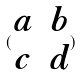Convert formula to latex. <formula><loc_0><loc_0><loc_500><loc_500>( \begin{matrix} a & b \\ c & d \end{matrix} )</formula> 